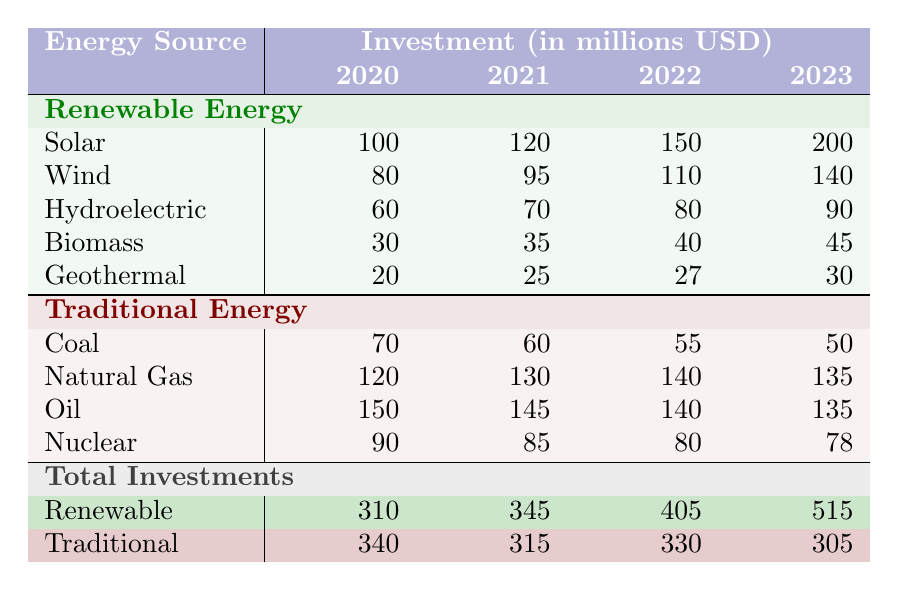What was the total investment in renewable energy in 2023? Looking at the row for "Renewable" under the total investments section, the value for 2023 is 515 million USD.
Answer: 515 million USD What was the investment in coal in 2020? Referring to the row for "Coal" under traditional energy investments, the value for 2020 is 70 million USD.
Answer: 70 million USD Which renewable energy source saw the highest investment increase from 2020 to 2023? Calculating the increase for each source: Solar increased by 100 million USD (from 100 to 200), Wind by 60 million USD (from 80 to 140), Hydroelectric by 30 million USD (from 60 to 90), Biomass by 15 million USD (from 30 to 45), and Geothermal by 10 million USD (from 20 to 30). The highest increase is from Solar.
Answer: Solar What is the average investment in traditional energy over the years 2020 to 2023? Summing the investments for traditional energy (340 + 315 + 330 + 305) gives 1290 million USD. There are 4 years, so the average is 1290/4 = 322.5 million USD.
Answer: 322.5 million USD Did the total investment in renewable energy surpass that of traditional energy in 2023? The total for renewable energy in 2023 is 515 million USD, whereas traditional energy's total is 305 million USD. Since 515 is greater than 305, the statement is true.
Answer: Yes What is the combined investment in wind and solar energy in 2022? The investment in Solar in 2022 is 150 million USD, and in Wind, it is 110 million USD. Adding these together gives 150 + 110 = 260 million USD.
Answer: 260 million USD What trend can be observed in coal investments from 2020 to 2023? The values for coal investments show a decreasing trend: 70 million USD in 2020, 60 million USD in 2021, 55 million USD in 2022, and 50 million USD in 2023.
Answer: Decreasing trend Which traditional energy source had the largest investment in 2021, and what was the amount? Natural Gas had the largest investment in 2021 with 130 million USD, as seen in the respective row under traditional energy investments.
Answer: Natural Gas, 130 million USD Which renewable energy source had the smallest total investment from 2020 to 2023? Adding the investments for each renewable source from the years given: Biomass (30+35+40+45 = 150), Geothermal (20+25+27+30 = 102) shows Geothermal has the smallest total investment of 102 million USD.
Answer: Geothermal What was the percentage change in total investments for traditional energy from 2020 to 2023? The total investments in traditional energy decreased from 340 million USD in 2020 to 305 million USD in 2023. The percentage change is calculated as ((305 - 340) / 340) * 100 = -10.29%.
Answer: -10.29% 